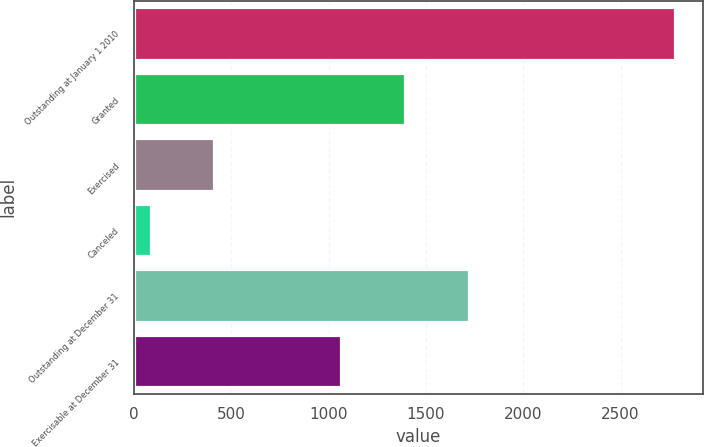<chart> <loc_0><loc_0><loc_500><loc_500><bar_chart><fcel>Outstanding at January 1 2010<fcel>Granted<fcel>Exercised<fcel>Canceled<fcel>Outstanding at December 31<fcel>Exercisable at December 31<nl><fcel>2782<fcel>1391.6<fcel>410.9<fcel>84<fcel>1718.5<fcel>1064.7<nl></chart> 